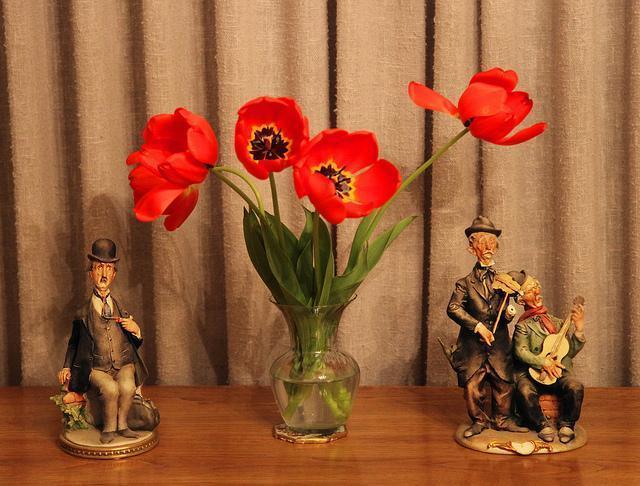How many dining tables can be seen?
Give a very brief answer. 1. How many beds are in the hotel room?
Give a very brief answer. 0. 